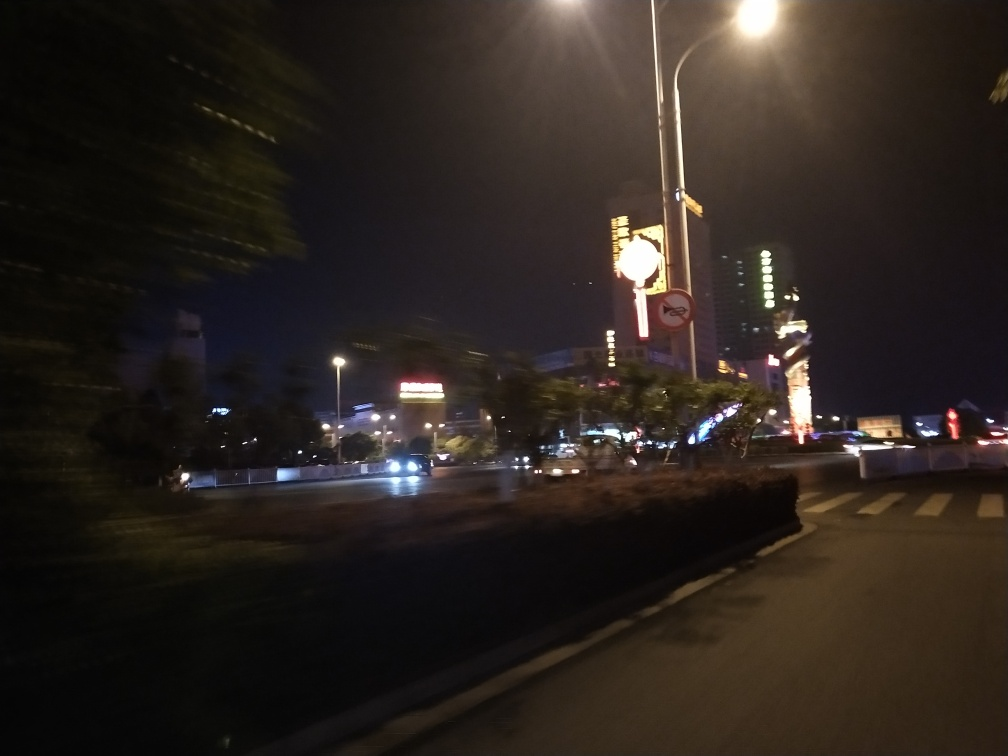Is the street blurry?
A. Yes
B. No
Answer with the option's letter from the given choices directly.
 A. 